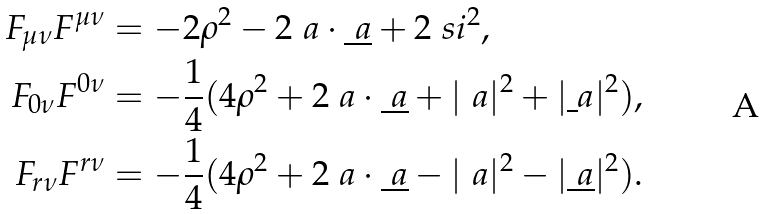<formula> <loc_0><loc_0><loc_500><loc_500>F _ { \mu \nu } F ^ { \mu \nu } & = - 2 \rho ^ { 2 } - 2 \ a \cdot \underline { \ a } + 2 \ s i ^ { 2 } , \\ F _ { 0 \nu } F ^ { 0 \nu } & = - \frac { 1 } { 4 } ( 4 \rho ^ { 2 } + 2 \ a \cdot \underline { \ a } + | \ a | ^ { 2 } + | \underline { \ } a | ^ { 2 } ) , \\ F _ { r \nu } F ^ { r \nu } & = - \frac { 1 } { 4 } ( 4 \rho ^ { 2 } + 2 \ a \cdot \underline { \ a } - | \ a | ^ { 2 } - | \underline { \ a } | ^ { 2 } ) .</formula> 